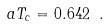<formula> <loc_0><loc_0><loc_500><loc_500>a T _ { c } = 0 . 6 4 2 \ .</formula> 